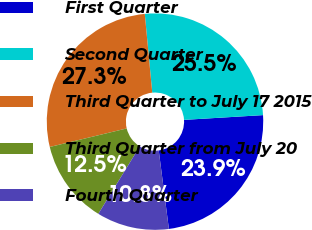Convert chart to OTSL. <chart><loc_0><loc_0><loc_500><loc_500><pie_chart><fcel>First Quarter<fcel>Second Quarter<fcel>Third Quarter to July 17 2015<fcel>Third Quarter from July 20<fcel>Fourth Quarter<nl><fcel>23.91%<fcel>25.55%<fcel>27.26%<fcel>12.47%<fcel>10.82%<nl></chart> 